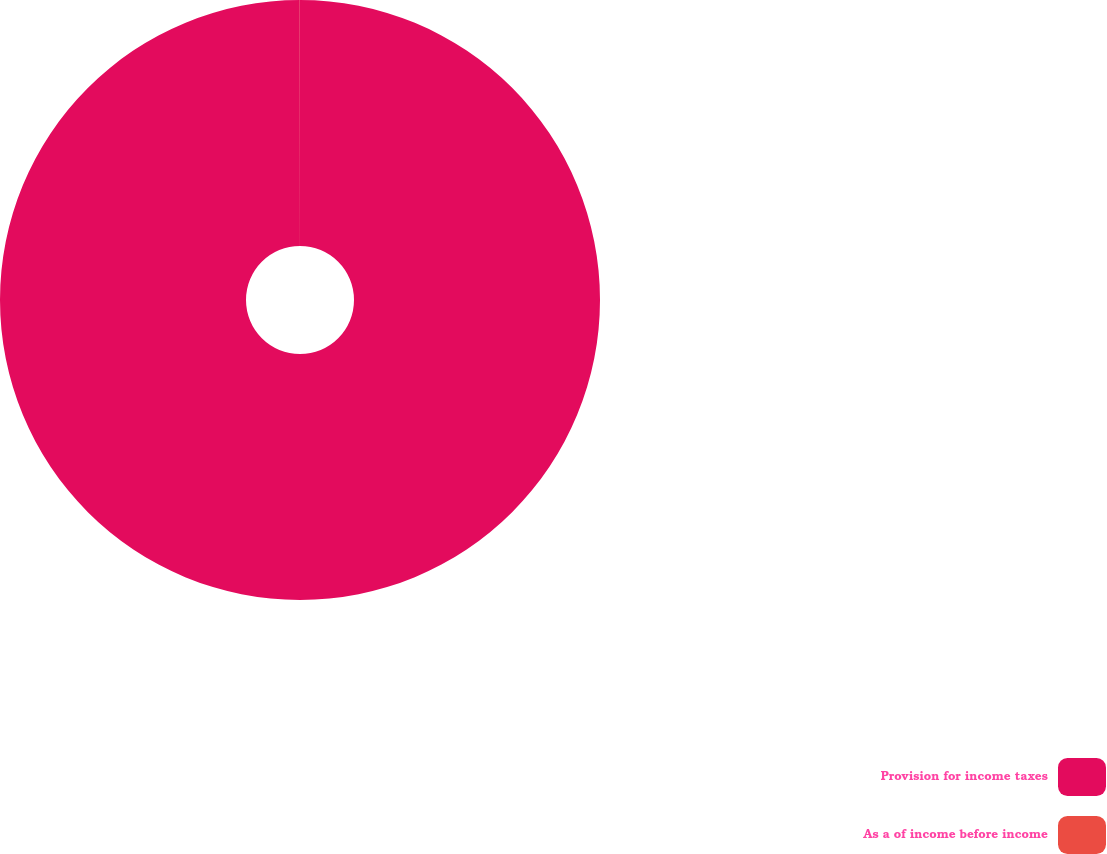Convert chart to OTSL. <chart><loc_0><loc_0><loc_500><loc_500><pie_chart><fcel>Provision for income taxes<fcel>As a of income before income<nl><fcel>99.99%<fcel>0.01%<nl></chart> 